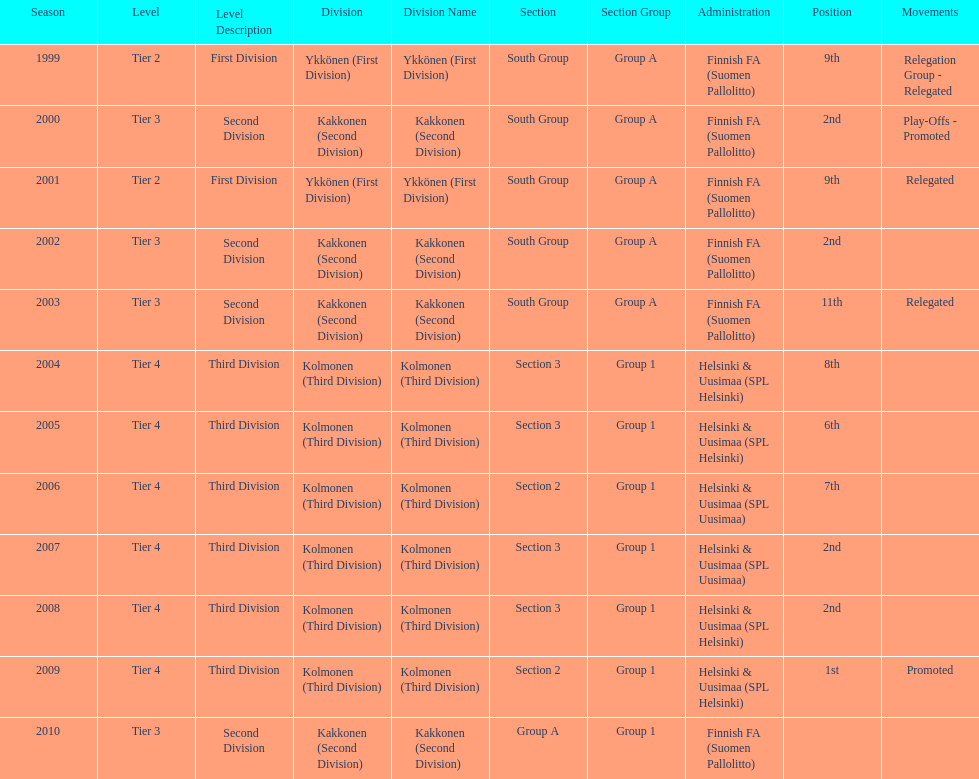How many consecutive times did they play in tier 4? 6. 